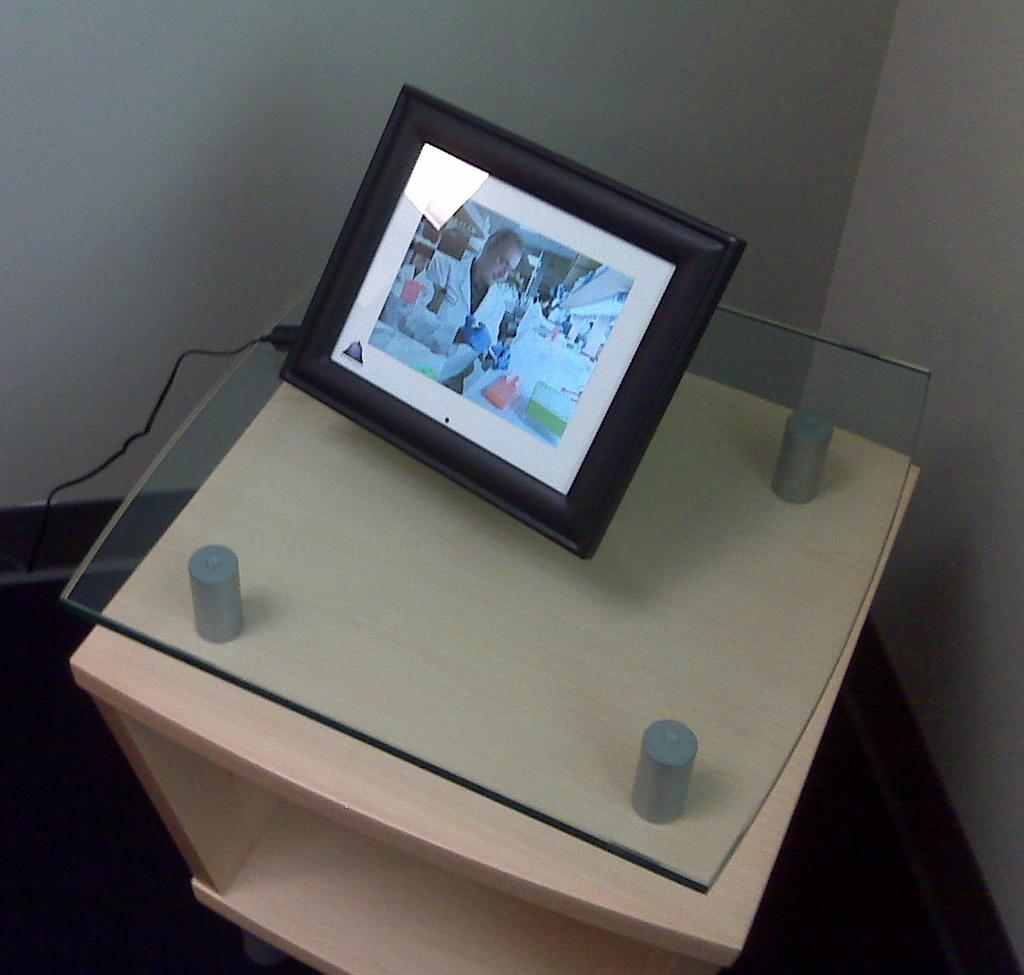What piece of furniture is present in the image? There is a table in the image. What object is placed on the table? There is a photo frame on the table. What is depicted in the photo frame? The photo frame contains a photo of a man. What can be seen on the left side of the image? There is a wire on the left side of the image. What type of pets are present in the image? There are no pets visible in the image. What is the level of harmony in the image? The concept of harmony is not applicable to the objects and subjects present in the image. 